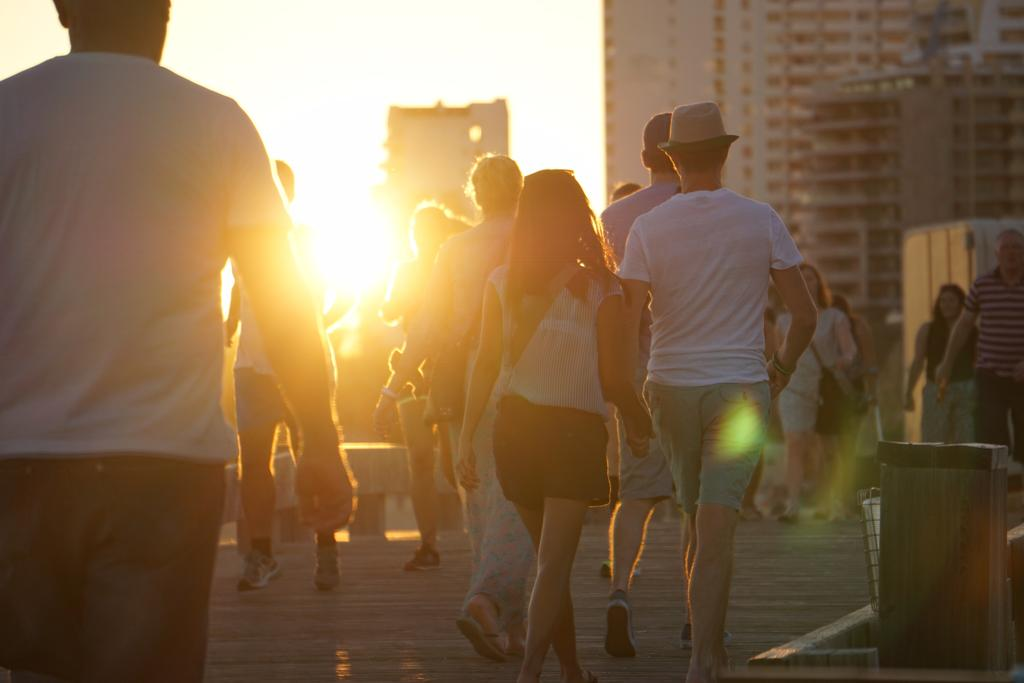What are the people in the image doing? The people in the image are walking. What type of surface are they walking on? The surface they are walking on is wooden. Can you describe the background of the image? The background of the image is blurred, but there are buildings and sunlight visible. What part of the natural environment can be seen in the image? The sky is visible in the background. What type of pies are being served in the image? There are no pies present in the image; it features people walking on a wooden surface with a blurred background. How does the acoustics of the space affect the sound of footsteps in the image? The image does not provide enough information about the acoustics of the space to determine how it might affect the sound of footsteps. 